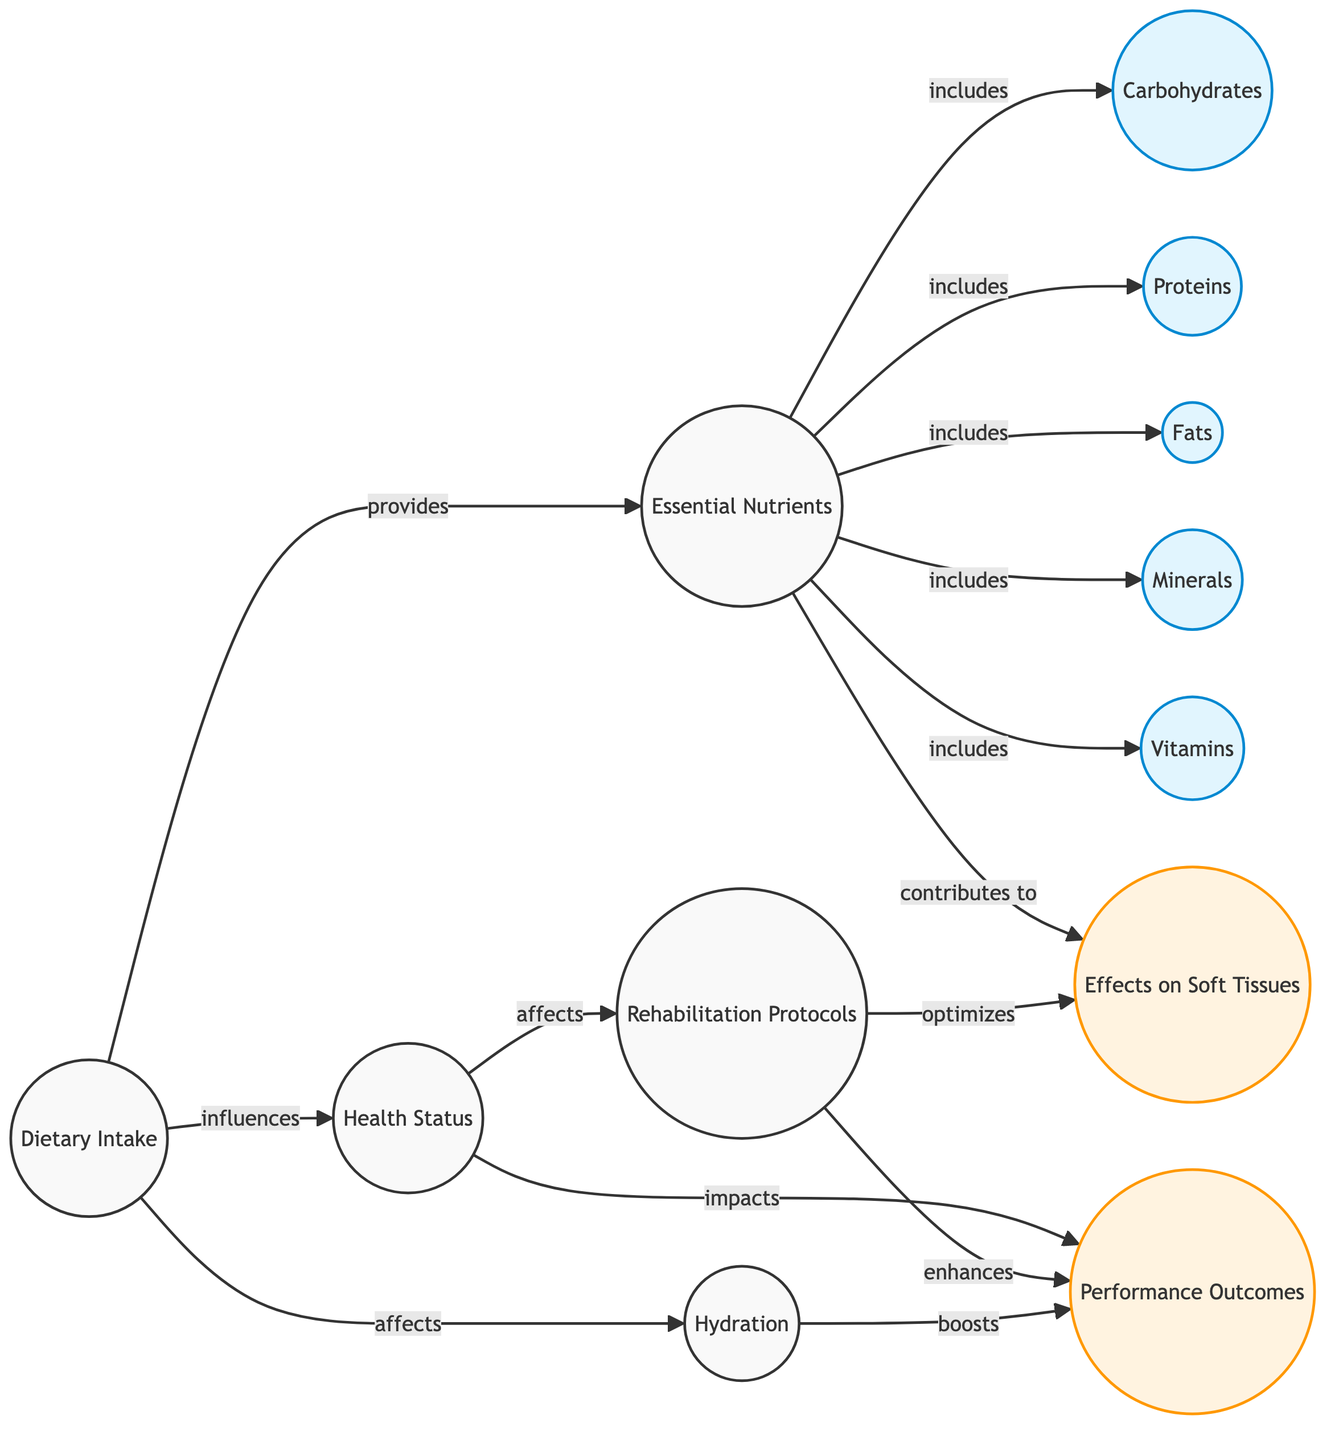what nodes are included in the nutrients category? The nutrients category node connects to five specific nodes: carbohydrates, proteins, fats, minerals, and vitamins, as indicated by the "includes" relationships.
Answer: carbohydrates, proteins, fats, minerals, vitamins how many edges are there in this diagram? The total number of edges connecting the nodes can be counted directly from the relationships depicted in the diagram. There are 12 edges in total based on the connections specifying various relationships such as "provides", "includes", "affects", and others.
Answer: 12 what is the relationship between health status and performance? The diagram shows a direct line from health status to performance, indicating the relationship as "impacts", which means health status has a significant effect on performance outcomes.
Answer: impacts which factor boosts performance outcomes? The diagram indicates that hydration is directly linked to performance through the "boosts" relationship. In this context, hydration is crucial for improving performance.
Answer: hydration what factors are included under essential nutrients that contribute to soft tissues? The nutrients node includes carbohydrates, proteins, fats, minerals, and vitamins, all of which jointly contribute to the effects on soft tissues as shown by their connection to the affer effects node.
Answer: carbohydrates, proteins, fats, minerals, vitamins how does dietary intake influence health status? The connection labeled as "influences" from dietary intake to health status suggests that the quality and quantity of what a horse consumes directly affect its overall health status, establishing a significant relationship.
Answer: influences what effects does the rehabilitation protocol have on performance? There are two direct influences from rehabilitation to performance in the diagram: it enhances performance outcomes and optimizes effects on soft tissues, indicating a strong positive impact of rehabilitation on performance.
Answer: enhances is there any direct connection between dietary intake and essential nutrients? Yes, the diagram shows a direct connection where dietary intake "provides" essential nutrients, demonstrating that the diet directly supplies the necessary nutrients for the horse.
Answer: provides what is the link between hydration and performance? The diagram indicates that hydration "boosts" performance, suggesting that adequate hydration levels are crucial for enhancing the performance outcomes of the horse during therapy and rehabilitation.
Answer: boosts 